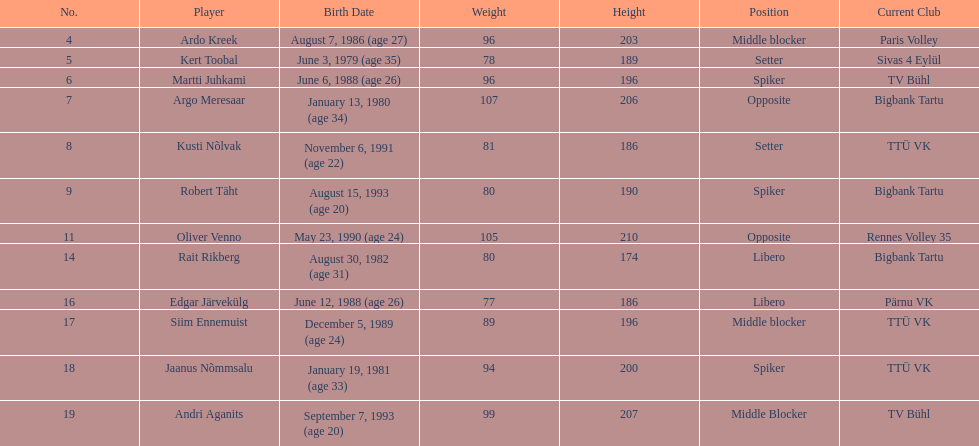How many players were born before 1988? 5. 